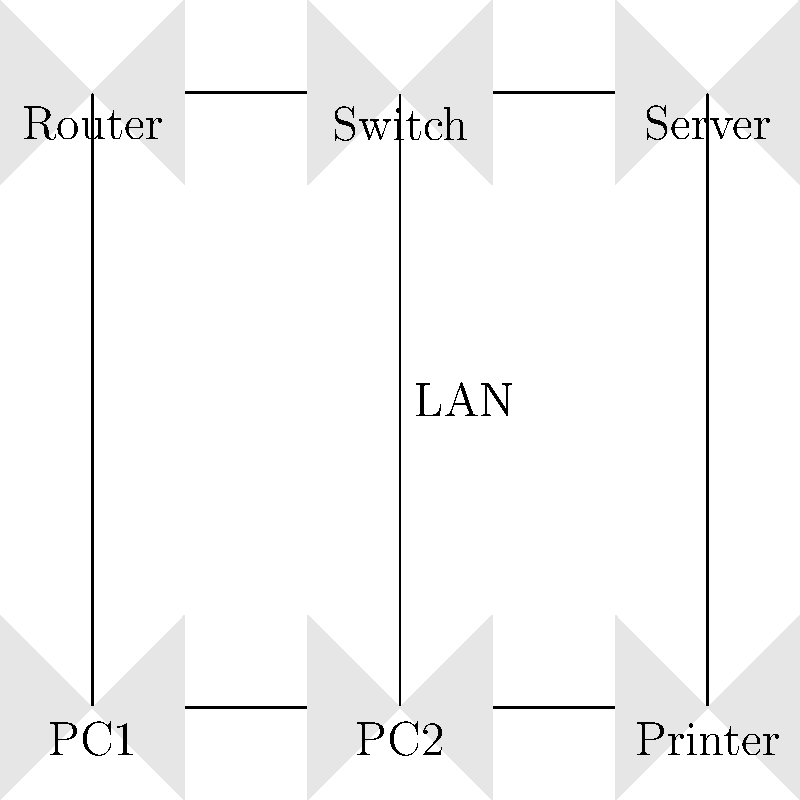In the given network topology diagram for a small office setup, which device is responsible for connecting all the other devices within the local area network (LAN)? To answer this question, let's analyze the components of the network topology diagram:

1. We can see six devices in the diagram: Router, Switch, Server, PC1, PC2, and Printer.

2. The Router is typically used to connect the local network to external networks or the internet. It's not primarily responsible for connecting devices within the LAN.

3. The Server, PCs, and Printer are end devices that need to be connected to the network.

4. The Switch is centrally located in the diagram and appears to have connections to all other devices.

5. In a typical small office network, a switch is used to connect multiple devices within the same local area network (LAN). It allows these devices to communicate with each other efficiently.

6. The switch operates at the data link layer (Layer 2) of the OSI model, using MAC addresses to forward data to the correct device within the LAN.

7. Unlike a hub, which broadcasts data to all connected devices, a switch intelligently directs traffic only to the intended recipient, improving network efficiency.

Based on this analysis, we can conclude that the Switch is the device responsible for connecting all the other devices within the local area network (LAN) in this small office setup.
Answer: Switch 